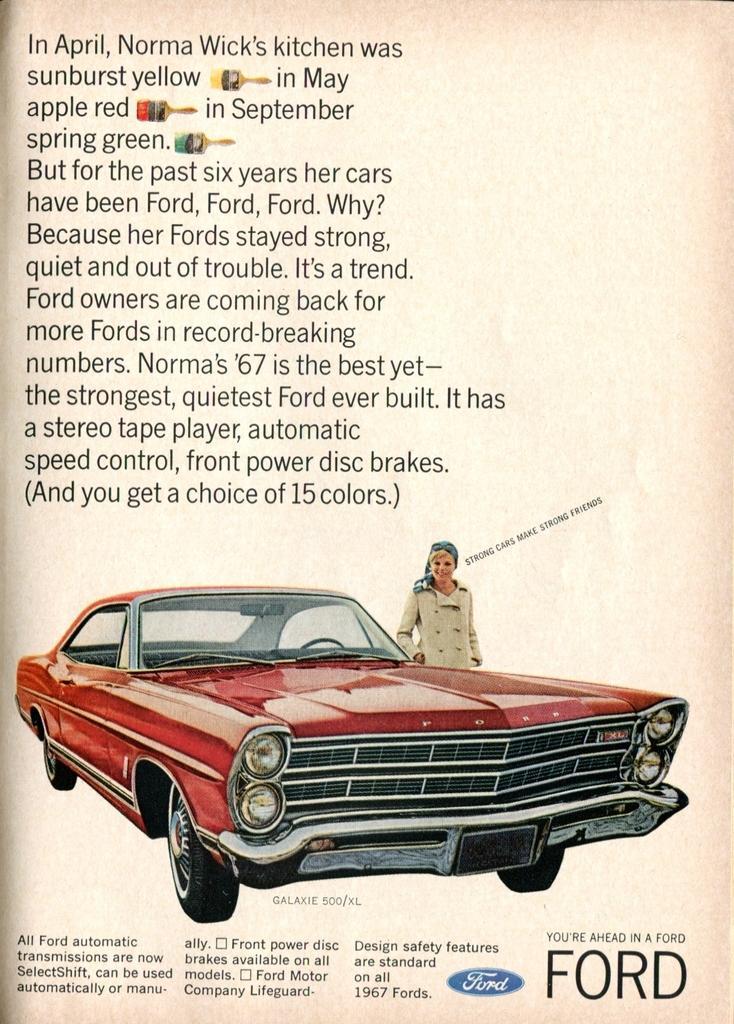In one or two sentences, can you explain what this image depicts? In this picture we can see the poster, on it we can see pictures and text. 